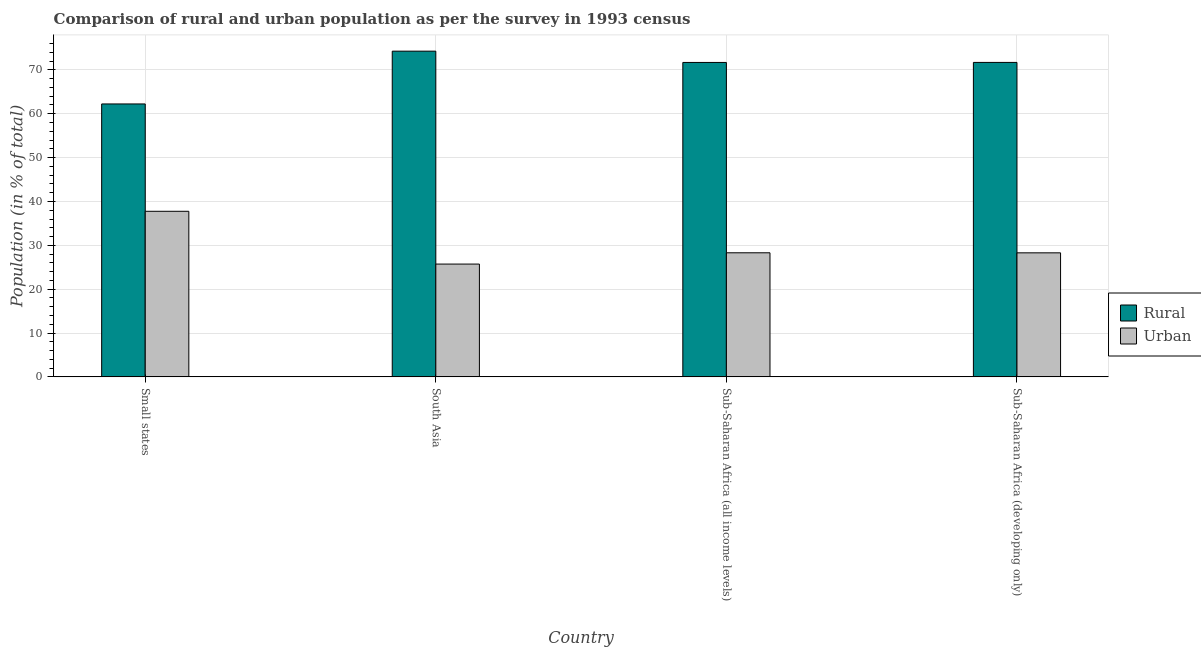How many different coloured bars are there?
Your answer should be very brief. 2. Are the number of bars on each tick of the X-axis equal?
Make the answer very short. Yes. How many bars are there on the 4th tick from the left?
Offer a very short reply. 2. How many bars are there on the 2nd tick from the right?
Make the answer very short. 2. What is the label of the 4th group of bars from the left?
Ensure brevity in your answer.  Sub-Saharan Africa (developing only). In how many cases, is the number of bars for a given country not equal to the number of legend labels?
Your response must be concise. 0. What is the rural population in Sub-Saharan Africa (all income levels)?
Offer a very short reply. 71.7. Across all countries, what is the maximum rural population?
Keep it short and to the point. 74.28. Across all countries, what is the minimum urban population?
Make the answer very short. 25.72. In which country was the rural population maximum?
Offer a very short reply. South Asia. In which country was the rural population minimum?
Make the answer very short. Small states. What is the total urban population in the graph?
Your answer should be compact. 120.07. What is the difference between the urban population in Small states and that in Sub-Saharan Africa (developing only)?
Provide a succinct answer. 9.47. What is the difference between the rural population in Small states and the urban population in Sub-Saharan Africa (developing only)?
Keep it short and to the point. 33.95. What is the average rural population per country?
Provide a short and direct response. 69.98. What is the difference between the urban population and rural population in South Asia?
Give a very brief answer. -48.55. What is the ratio of the rural population in Sub-Saharan Africa (all income levels) to that in Sub-Saharan Africa (developing only)?
Offer a terse response. 1. Is the urban population in Small states less than that in South Asia?
Your response must be concise. No. Is the difference between the rural population in Small states and South Asia greater than the difference between the urban population in Small states and South Asia?
Make the answer very short. No. What is the difference between the highest and the second highest urban population?
Make the answer very short. 9.46. What is the difference between the highest and the lowest urban population?
Give a very brief answer. 12.04. In how many countries, is the urban population greater than the average urban population taken over all countries?
Give a very brief answer. 1. Is the sum of the rural population in South Asia and Sub-Saharan Africa (all income levels) greater than the maximum urban population across all countries?
Offer a very short reply. Yes. What does the 1st bar from the left in Small states represents?
Your answer should be compact. Rural. What does the 1st bar from the right in Sub-Saharan Africa (developing only) represents?
Your response must be concise. Urban. Are all the bars in the graph horizontal?
Give a very brief answer. No. How many countries are there in the graph?
Offer a terse response. 4. What is the difference between two consecutive major ticks on the Y-axis?
Give a very brief answer. 10. Are the values on the major ticks of Y-axis written in scientific E-notation?
Keep it short and to the point. No. Does the graph contain any zero values?
Offer a very short reply. No. Does the graph contain grids?
Give a very brief answer. Yes. Where does the legend appear in the graph?
Offer a very short reply. Center right. How are the legend labels stacked?
Provide a succinct answer. Vertical. What is the title of the graph?
Offer a very short reply. Comparison of rural and urban population as per the survey in 1993 census. Does "Secondary education" appear as one of the legend labels in the graph?
Your answer should be compact. No. What is the label or title of the Y-axis?
Your response must be concise. Population (in % of total). What is the Population (in % of total) of Rural in Small states?
Offer a terse response. 62.24. What is the Population (in % of total) in Urban in Small states?
Ensure brevity in your answer.  37.76. What is the Population (in % of total) in Rural in South Asia?
Offer a terse response. 74.28. What is the Population (in % of total) of Urban in South Asia?
Provide a succinct answer. 25.72. What is the Population (in % of total) of Rural in Sub-Saharan Africa (all income levels)?
Your response must be concise. 71.7. What is the Population (in % of total) of Urban in Sub-Saharan Africa (all income levels)?
Provide a succinct answer. 28.3. What is the Population (in % of total) in Rural in Sub-Saharan Africa (developing only)?
Offer a terse response. 71.71. What is the Population (in % of total) of Urban in Sub-Saharan Africa (developing only)?
Your response must be concise. 28.29. Across all countries, what is the maximum Population (in % of total) of Rural?
Give a very brief answer. 74.28. Across all countries, what is the maximum Population (in % of total) in Urban?
Provide a succinct answer. 37.76. Across all countries, what is the minimum Population (in % of total) in Rural?
Ensure brevity in your answer.  62.24. Across all countries, what is the minimum Population (in % of total) of Urban?
Make the answer very short. 25.72. What is the total Population (in % of total) in Rural in the graph?
Offer a very short reply. 279.93. What is the total Population (in % of total) in Urban in the graph?
Offer a very short reply. 120.07. What is the difference between the Population (in % of total) of Rural in Small states and that in South Asia?
Your response must be concise. -12.04. What is the difference between the Population (in % of total) of Urban in Small states and that in South Asia?
Make the answer very short. 12.04. What is the difference between the Population (in % of total) in Rural in Small states and that in Sub-Saharan Africa (all income levels)?
Your answer should be very brief. -9.46. What is the difference between the Population (in % of total) of Urban in Small states and that in Sub-Saharan Africa (all income levels)?
Offer a very short reply. 9.46. What is the difference between the Population (in % of total) in Rural in Small states and that in Sub-Saharan Africa (developing only)?
Make the answer very short. -9.47. What is the difference between the Population (in % of total) of Urban in Small states and that in Sub-Saharan Africa (developing only)?
Give a very brief answer. 9.47. What is the difference between the Population (in % of total) in Rural in South Asia and that in Sub-Saharan Africa (all income levels)?
Provide a short and direct response. 2.57. What is the difference between the Population (in % of total) in Urban in South Asia and that in Sub-Saharan Africa (all income levels)?
Your answer should be compact. -2.57. What is the difference between the Population (in % of total) in Rural in South Asia and that in Sub-Saharan Africa (developing only)?
Ensure brevity in your answer.  2.56. What is the difference between the Population (in % of total) in Urban in South Asia and that in Sub-Saharan Africa (developing only)?
Give a very brief answer. -2.56. What is the difference between the Population (in % of total) of Rural in Sub-Saharan Africa (all income levels) and that in Sub-Saharan Africa (developing only)?
Your answer should be compact. -0.01. What is the difference between the Population (in % of total) in Urban in Sub-Saharan Africa (all income levels) and that in Sub-Saharan Africa (developing only)?
Ensure brevity in your answer.  0.01. What is the difference between the Population (in % of total) in Rural in Small states and the Population (in % of total) in Urban in South Asia?
Your answer should be compact. 36.52. What is the difference between the Population (in % of total) in Rural in Small states and the Population (in % of total) in Urban in Sub-Saharan Africa (all income levels)?
Your answer should be very brief. 33.94. What is the difference between the Population (in % of total) of Rural in Small states and the Population (in % of total) of Urban in Sub-Saharan Africa (developing only)?
Your answer should be very brief. 33.95. What is the difference between the Population (in % of total) of Rural in South Asia and the Population (in % of total) of Urban in Sub-Saharan Africa (all income levels)?
Provide a short and direct response. 45.98. What is the difference between the Population (in % of total) of Rural in South Asia and the Population (in % of total) of Urban in Sub-Saharan Africa (developing only)?
Your answer should be compact. 45.99. What is the difference between the Population (in % of total) in Rural in Sub-Saharan Africa (all income levels) and the Population (in % of total) in Urban in Sub-Saharan Africa (developing only)?
Provide a succinct answer. 43.42. What is the average Population (in % of total) of Rural per country?
Keep it short and to the point. 69.98. What is the average Population (in % of total) in Urban per country?
Offer a very short reply. 30.02. What is the difference between the Population (in % of total) of Rural and Population (in % of total) of Urban in Small states?
Offer a terse response. 24.48. What is the difference between the Population (in % of total) of Rural and Population (in % of total) of Urban in South Asia?
Offer a very short reply. 48.55. What is the difference between the Population (in % of total) in Rural and Population (in % of total) in Urban in Sub-Saharan Africa (all income levels)?
Offer a very short reply. 43.41. What is the difference between the Population (in % of total) of Rural and Population (in % of total) of Urban in Sub-Saharan Africa (developing only)?
Keep it short and to the point. 43.43. What is the ratio of the Population (in % of total) of Rural in Small states to that in South Asia?
Your answer should be very brief. 0.84. What is the ratio of the Population (in % of total) in Urban in Small states to that in South Asia?
Keep it short and to the point. 1.47. What is the ratio of the Population (in % of total) in Rural in Small states to that in Sub-Saharan Africa (all income levels)?
Your answer should be very brief. 0.87. What is the ratio of the Population (in % of total) in Urban in Small states to that in Sub-Saharan Africa (all income levels)?
Provide a succinct answer. 1.33. What is the ratio of the Population (in % of total) of Rural in Small states to that in Sub-Saharan Africa (developing only)?
Offer a very short reply. 0.87. What is the ratio of the Population (in % of total) of Urban in Small states to that in Sub-Saharan Africa (developing only)?
Provide a short and direct response. 1.33. What is the ratio of the Population (in % of total) of Rural in South Asia to that in Sub-Saharan Africa (all income levels)?
Your answer should be very brief. 1.04. What is the ratio of the Population (in % of total) of Urban in South Asia to that in Sub-Saharan Africa (all income levels)?
Make the answer very short. 0.91. What is the ratio of the Population (in % of total) in Rural in South Asia to that in Sub-Saharan Africa (developing only)?
Ensure brevity in your answer.  1.04. What is the ratio of the Population (in % of total) of Urban in South Asia to that in Sub-Saharan Africa (developing only)?
Ensure brevity in your answer.  0.91. What is the difference between the highest and the second highest Population (in % of total) of Rural?
Make the answer very short. 2.56. What is the difference between the highest and the second highest Population (in % of total) in Urban?
Make the answer very short. 9.46. What is the difference between the highest and the lowest Population (in % of total) of Rural?
Offer a terse response. 12.04. What is the difference between the highest and the lowest Population (in % of total) in Urban?
Keep it short and to the point. 12.04. 